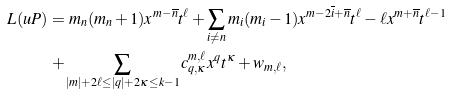Convert formula to latex. <formula><loc_0><loc_0><loc_500><loc_500>L ( u P ) = & \ m _ { n } ( m _ { n } + 1 ) x ^ { m - \overline { n } } t ^ { \ell } + \sum _ { i \neq n } m _ { i } ( m _ { i } - 1 ) x ^ { m - 2 \overline { i } + \overline { n } } t ^ { \ell } - \ell x ^ { m + \overline { n } } t ^ { \ell - 1 } \\ + & \sum _ { | m | + 2 \ell \leq | q | + 2 \kappa \leq k - 1 } c ^ { m , \ell } _ { q , \kappa } x ^ { q } t ^ { \kappa } + w _ { m , \ell } ,</formula> 